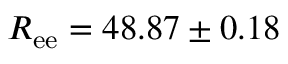Convert formula to latex. <formula><loc_0><loc_0><loc_500><loc_500>R _ { e e } = 4 8 . 8 7 \pm 0 . 1 8</formula> 